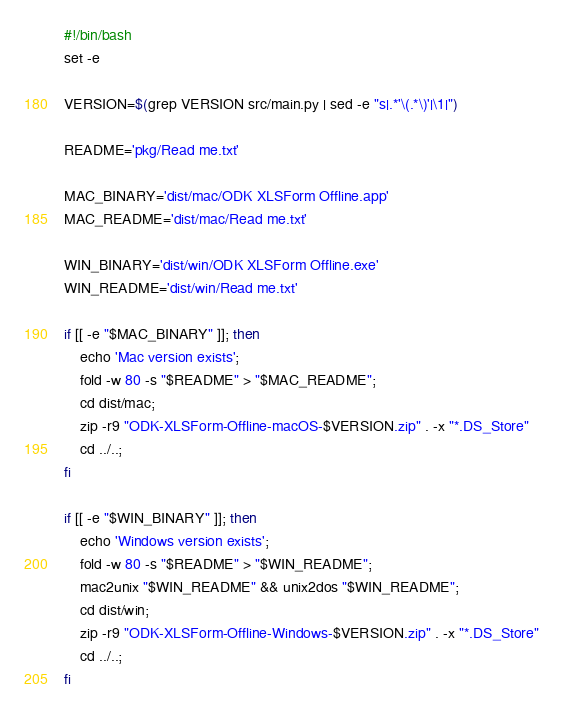Convert code to text. <code><loc_0><loc_0><loc_500><loc_500><_Bash_>#!/bin/bash
set -e

VERSION=$(grep VERSION src/main.py | sed -e "s|.*'\(.*\)'|\1|")

README='pkg/Read me.txt'

MAC_BINARY='dist/mac/ODK XLSForm Offline.app'
MAC_README='dist/mac/Read me.txt'

WIN_BINARY='dist/win/ODK XLSForm Offline.exe'
WIN_README='dist/win/Read me.txt'

if [[ -e "$MAC_BINARY" ]]; then
	echo 'Mac version exists';
	fold -w 80 -s "$README" > "$MAC_README";
	cd dist/mac;
	zip -r9 "ODK-XLSForm-Offline-macOS-$VERSION.zip" . -x "*.DS_Store"
	cd ../..;
fi

if [[ -e "$WIN_BINARY" ]]; then
	echo 'Windows version exists';
	fold -w 80 -s "$README" > "$WIN_README";
	mac2unix "$WIN_README" && unix2dos "$WIN_README";
	cd dist/win;
	zip -r9 "ODK-XLSForm-Offline-Windows-$VERSION.zip" . -x "*.DS_Store"
	cd ../..;
fi</code> 